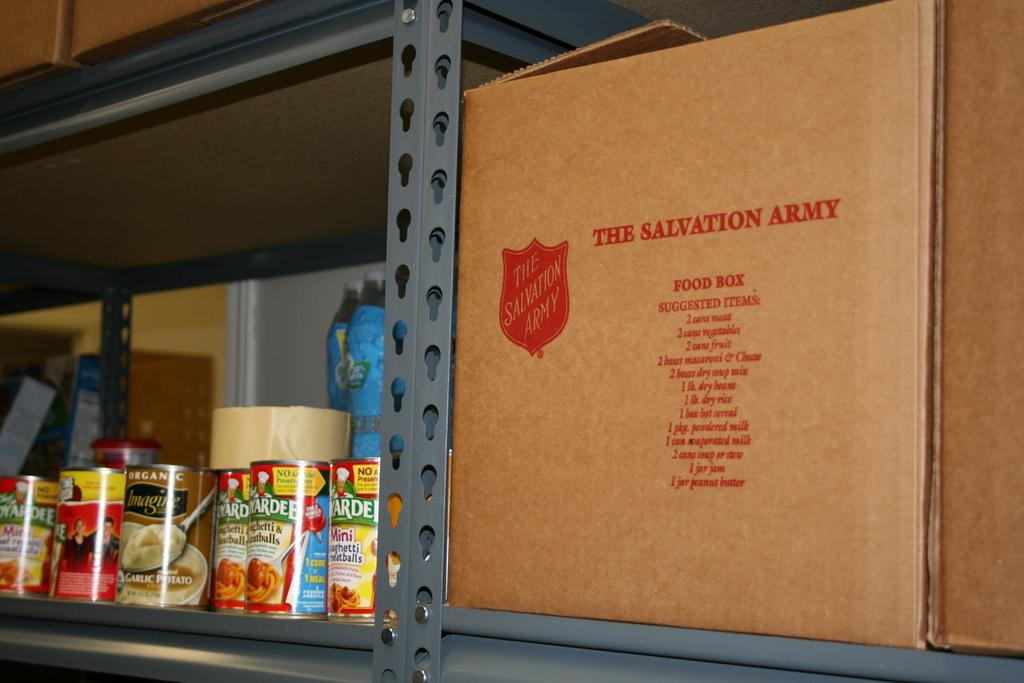<image>
Offer a succinct explanation of the picture presented. A Salvation Army cardboard box sits on a metal shelf next to some canned foods. 